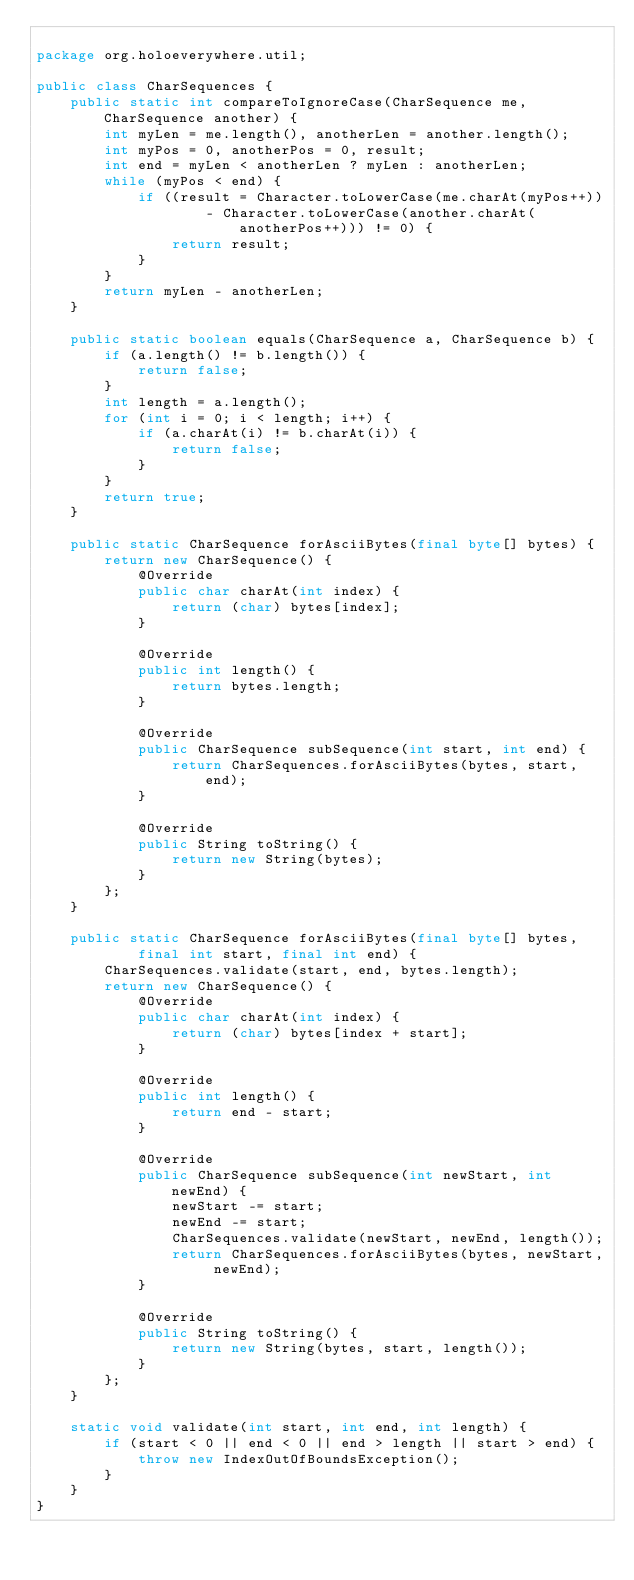<code> <loc_0><loc_0><loc_500><loc_500><_Java_>
package org.holoeverywhere.util;

public class CharSequences {
    public static int compareToIgnoreCase(CharSequence me, CharSequence another) {
        int myLen = me.length(), anotherLen = another.length();
        int myPos = 0, anotherPos = 0, result;
        int end = myLen < anotherLen ? myLen : anotherLen;
        while (myPos < end) {
            if ((result = Character.toLowerCase(me.charAt(myPos++))
                    - Character.toLowerCase(another.charAt(anotherPos++))) != 0) {
                return result;
            }
        }
        return myLen - anotherLen;
    }

    public static boolean equals(CharSequence a, CharSequence b) {
        if (a.length() != b.length()) {
            return false;
        }
        int length = a.length();
        for (int i = 0; i < length; i++) {
            if (a.charAt(i) != b.charAt(i)) {
                return false;
            }
        }
        return true;
    }

    public static CharSequence forAsciiBytes(final byte[] bytes) {
        return new CharSequence() {
            @Override
            public char charAt(int index) {
                return (char) bytes[index];
            }

            @Override
            public int length() {
                return bytes.length;
            }

            @Override
            public CharSequence subSequence(int start, int end) {
                return CharSequences.forAsciiBytes(bytes, start, end);
            }

            @Override
            public String toString() {
                return new String(bytes);
            }
        };
    }

    public static CharSequence forAsciiBytes(final byte[] bytes,
            final int start, final int end) {
        CharSequences.validate(start, end, bytes.length);
        return new CharSequence() {
            @Override
            public char charAt(int index) {
                return (char) bytes[index + start];
            }

            @Override
            public int length() {
                return end - start;
            }

            @Override
            public CharSequence subSequence(int newStart, int newEnd) {
                newStart -= start;
                newEnd -= start;
                CharSequences.validate(newStart, newEnd, length());
                return CharSequences.forAsciiBytes(bytes, newStart, newEnd);
            }

            @Override
            public String toString() {
                return new String(bytes, start, length());
            }
        };
    }

    static void validate(int start, int end, int length) {
        if (start < 0 || end < 0 || end > length || start > end) {
            throw new IndexOutOfBoundsException();
        }
    }
}
</code> 